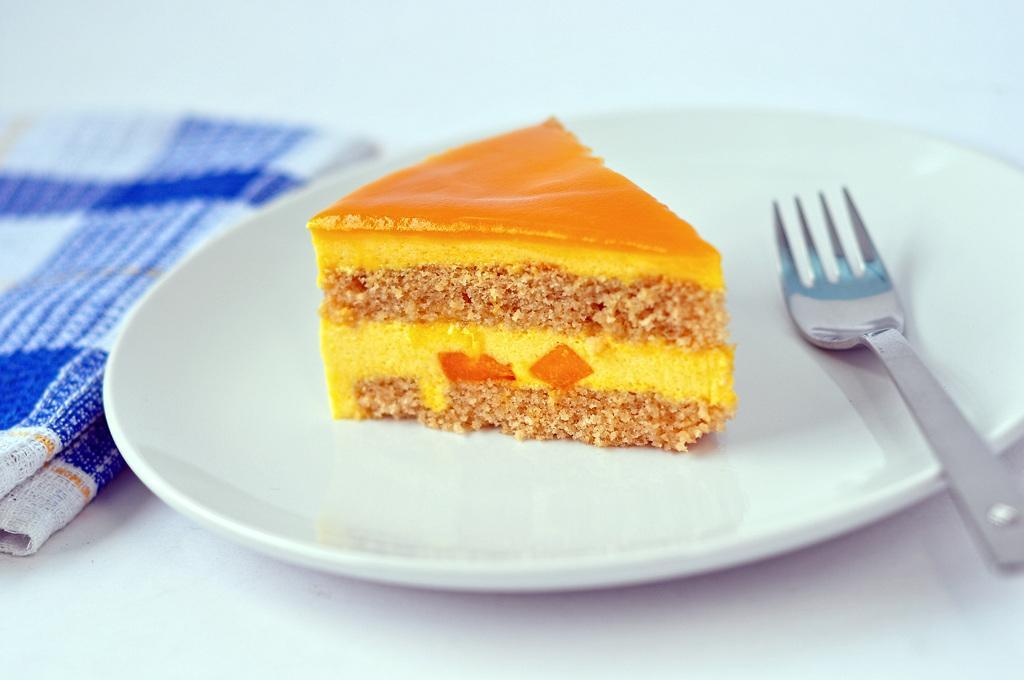In one or two sentences, can you explain what this image depicts? In the picture I can see a pastry which is yellow and orange in color which is in a plate, there is fork and the plate is white in color, on left side of the picture there is a cloth. 